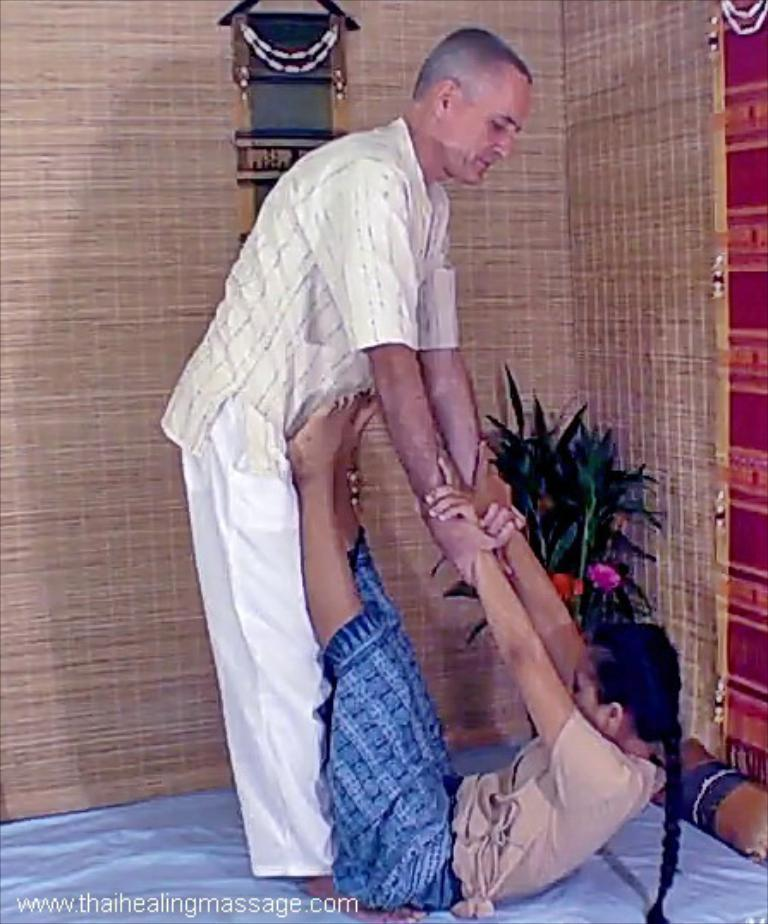Who is present in the image? There is a man in the image. What is the man doing in the image? The man is holding a girl with his hands. What can be seen in the background of the image? There is a house plant and a wooden object in the background of the image. What is the size of the glass in the image? There is no glass present in the image. 